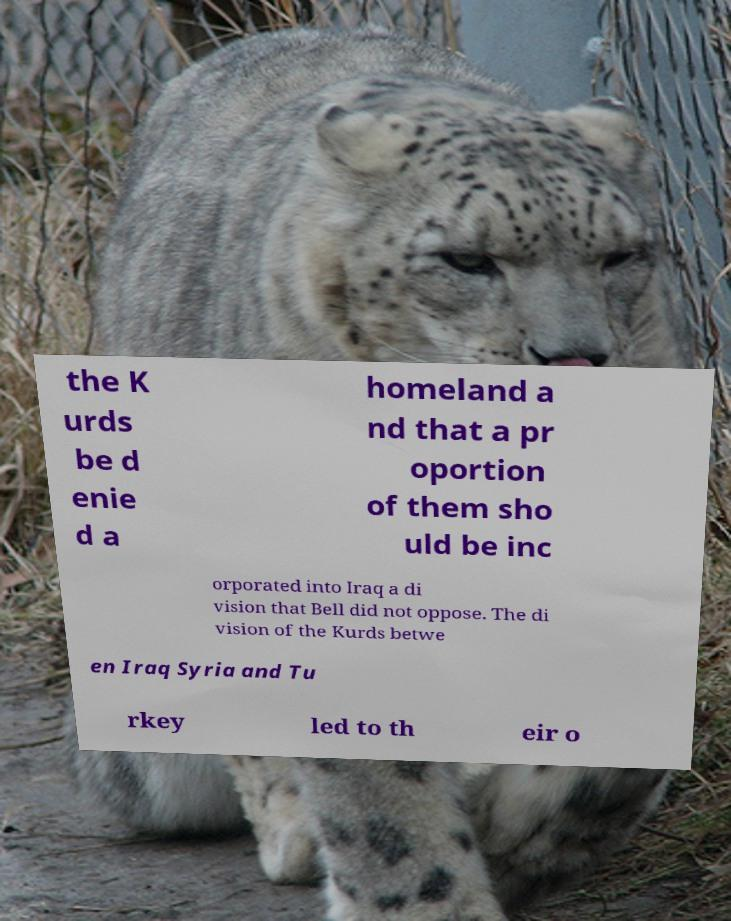I need the written content from this picture converted into text. Can you do that? the K urds be d enie d a homeland a nd that a pr oportion of them sho uld be inc orporated into Iraq a di vision that Bell did not oppose. The di vision of the Kurds betwe en Iraq Syria and Tu rkey led to th eir o 